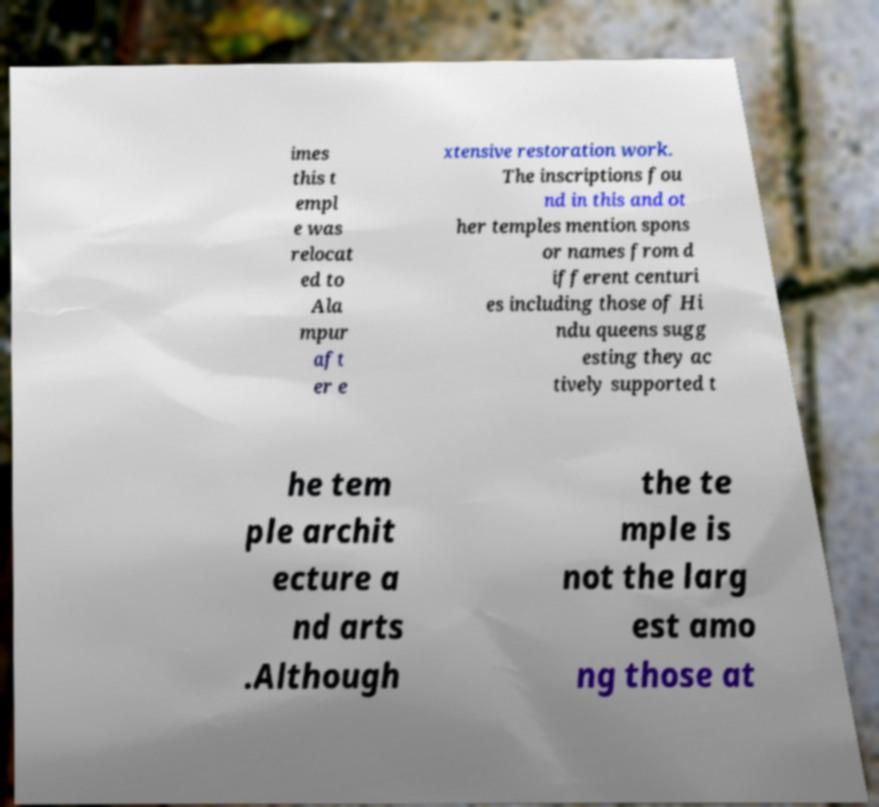What messages or text are displayed in this image? I need them in a readable, typed format. imes this t empl e was relocat ed to Ala mpur aft er e xtensive restoration work. The inscriptions fou nd in this and ot her temples mention spons or names from d ifferent centuri es including those of Hi ndu queens sugg esting they ac tively supported t he tem ple archit ecture a nd arts .Although the te mple is not the larg est amo ng those at 